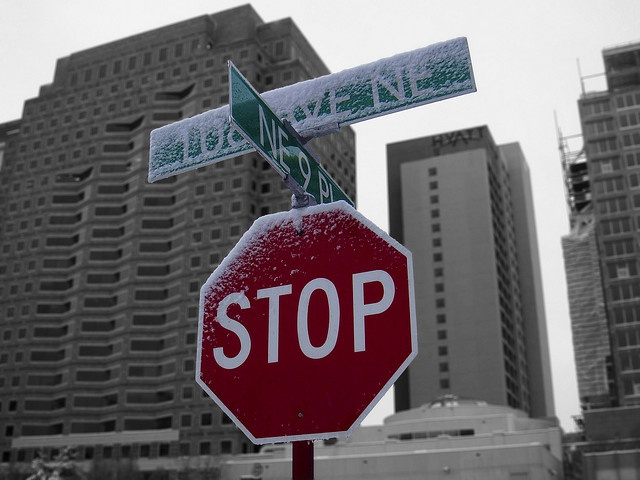Describe the objects in this image and their specific colors. I can see a stop sign in white, maroon, darkgray, and gray tones in this image. 